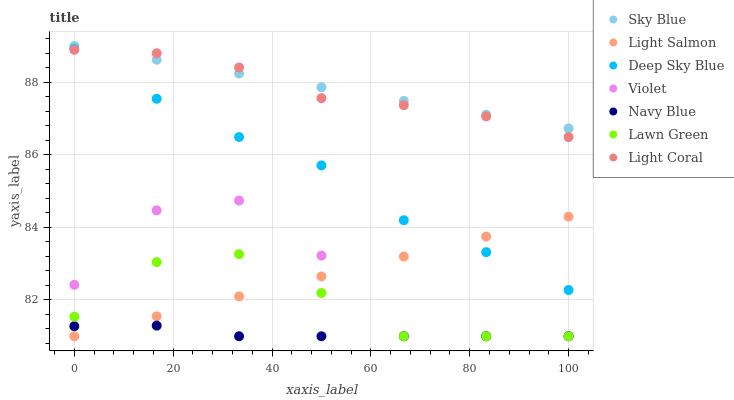Does Navy Blue have the minimum area under the curve?
Answer yes or no. Yes. Does Sky Blue have the maximum area under the curve?
Answer yes or no. Yes. Does Light Salmon have the minimum area under the curve?
Answer yes or no. No. Does Light Salmon have the maximum area under the curve?
Answer yes or no. No. Is Light Salmon the smoothest?
Answer yes or no. Yes. Is Violet the roughest?
Answer yes or no. Yes. Is Navy Blue the smoothest?
Answer yes or no. No. Is Navy Blue the roughest?
Answer yes or no. No. Does Lawn Green have the lowest value?
Answer yes or no. Yes. Does Light Coral have the lowest value?
Answer yes or no. No. Does Sky Blue have the highest value?
Answer yes or no. Yes. Does Light Salmon have the highest value?
Answer yes or no. No. Is Navy Blue less than Sky Blue?
Answer yes or no. Yes. Is Sky Blue greater than Navy Blue?
Answer yes or no. Yes. Does Violet intersect Light Salmon?
Answer yes or no. Yes. Is Violet less than Light Salmon?
Answer yes or no. No. Is Violet greater than Light Salmon?
Answer yes or no. No. Does Navy Blue intersect Sky Blue?
Answer yes or no. No. 